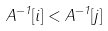Convert formula to latex. <formula><loc_0><loc_0><loc_500><loc_500>A ^ { - 1 } [ i ] < A ^ { - 1 } [ j ]</formula> 